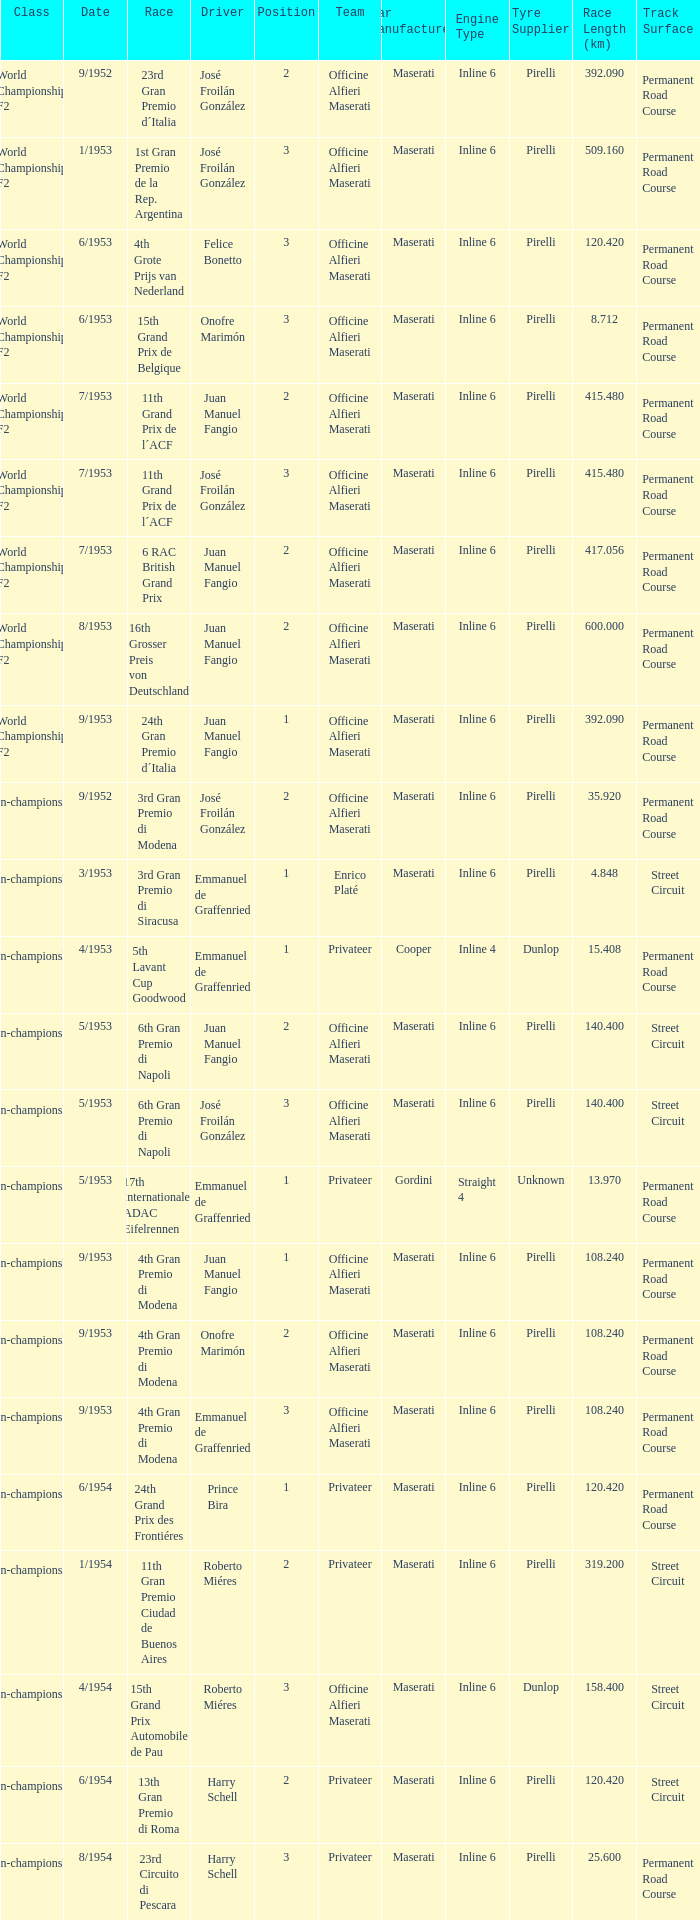What driver has a team of officine alfieri maserati and belongs to the class of non-championship f2 and has a position of 2, as well as a date of 9/1952? José Froilán González. Parse the table in full. {'header': ['Class', 'Date', 'Race', 'Driver', 'Position', 'Team', 'Car Manufacturer', 'Engine Type', 'Tyre Supplier', 'Race Length (km)', 'Track Surface'], 'rows': [['World Championship F2', '9/1952', '23rd Gran Premio d´Italia', 'José Froilán González', '2', 'Officine Alfieri Maserati', 'Maserati', 'Inline 6', 'Pirelli', '392.090', 'Permanent Road Course'], ['World Championship F2', '1/1953', '1st Gran Premio de la Rep. Argentina', 'José Froilán González', '3', 'Officine Alfieri Maserati', 'Maserati', 'Inline 6', 'Pirelli', '509.160', 'Permanent Road Course'], ['World Championship F2', '6/1953', '4th Grote Prijs van Nederland', 'Felice Bonetto', '3', 'Officine Alfieri Maserati', 'Maserati', 'Inline 6', 'Pirelli', '120.420', 'Permanent Road Course'], ['World Championship F2', '6/1953', '15th Grand Prix de Belgique', 'Onofre Marimón', '3', 'Officine Alfieri Maserati', 'Maserati', 'Inline 6', 'Pirelli', '8.712', 'Permanent Road Course'], ['World Championship F2', '7/1953', '11th Grand Prix de l´ACF', 'Juan Manuel Fangio', '2', 'Officine Alfieri Maserati', 'Maserati', 'Inline 6', 'Pirelli', '415.480', 'Permanent Road Course'], ['World Championship F2', '7/1953', '11th Grand Prix de l´ACF', 'José Froilán González', '3', 'Officine Alfieri Maserati', 'Maserati', 'Inline 6', 'Pirelli', '415.480', 'Permanent Road Course'], ['World Championship F2', '7/1953', '6 RAC British Grand Prix', 'Juan Manuel Fangio', '2', 'Officine Alfieri Maserati', 'Maserati', 'Inline 6', 'Pirelli', '417.056', 'Permanent Road Course'], ['World Championship F2', '8/1953', '16th Grosser Preis von Deutschland', 'Juan Manuel Fangio', '2', 'Officine Alfieri Maserati', 'Maserati', 'Inline 6', 'Pirelli', '600.000', 'Permanent Road Course'], ['World Championship F2', '9/1953', '24th Gran Premio d´Italia', 'Juan Manuel Fangio', '1', 'Officine Alfieri Maserati', 'Maserati', 'Inline 6', 'Pirelli', '392.090', 'Permanent Road Course'], ['Non-championship F2', '9/1952', '3rd Gran Premio di Modena', 'José Froilán González', '2', 'Officine Alfieri Maserati', 'Maserati', 'Inline 6', 'Pirelli', '35.920', 'Permanent Road Course'], ['Non-championship F2', '3/1953', '3rd Gran Premio di Siracusa', 'Emmanuel de Graffenried', '1', 'Enrico Platé', 'Maserati', 'Inline 6', 'Pirelli', '4.848', 'Street Circuit'], ['Non-championship F2', '4/1953', '5th Lavant Cup Goodwood', 'Emmanuel de Graffenried', '1', 'Privateer', 'Cooper', 'Inline 4', 'Dunlop', '15.408', 'Permanent Road Course'], ['Non-championship F2', '5/1953', '6th Gran Premio di Napoli', 'Juan Manuel Fangio', '2', 'Officine Alfieri Maserati', 'Maserati', 'Inline 6', 'Pirelli', '140.400', 'Street Circuit'], ['Non-championship F2', '5/1953', '6th Gran Premio di Napoli', 'José Froilán González', '3', 'Officine Alfieri Maserati', 'Maserati', 'Inline 6', 'Pirelli', '140.400', 'Street Circuit'], ['Non-championship F2', '5/1953', '17th Internationales ADAC Eifelrennen', 'Emmanuel de Graffenried', '1', 'Privateer', 'Gordini', 'Straight 4', 'Unknown', '13.970', 'Permanent Road Course'], ['Non-championship F2', '9/1953', '4th Gran Premio di Modena', 'Juan Manuel Fangio', '1', 'Officine Alfieri Maserati', 'Maserati', 'Inline 6', 'Pirelli', '108.240', 'Permanent Road Course'], ['Non-championship F2', '9/1953', '4th Gran Premio di Modena', 'Onofre Marimón', '2', 'Officine Alfieri Maserati', 'Maserati', 'Inline 6', 'Pirelli', '108.240', 'Permanent Road Course'], ['Non-championship F2', '9/1953', '4th Gran Premio di Modena', 'Emmanuel de Graffenried', '3', 'Officine Alfieri Maserati', 'Maserati', 'Inline 6', 'Pirelli', '108.240', 'Permanent Road Course'], ['(Non-championship) F2', '6/1954', '24th Grand Prix des Frontiéres', 'Prince Bira', '1', 'Privateer', 'Maserati', 'Inline 6', 'Pirelli', '120.420', 'Permanent Road Course'], ['Non-championship F1', '1/1954', '11th Gran Premio Ciudad de Buenos Aires', 'Roberto Miéres', '2', 'Privateer', 'Maserati', 'Inline 6', 'Pirelli', '319.200', 'Street Circuit'], ['Non-championship F1', '4/1954', '15th Grand Prix Automobile de Pau', 'Roberto Miéres', '3', 'Officine Alfieri Maserati', 'Maserati', 'Inline 6', 'Dunlop', '158.400', 'Street Circuit'], ['Non-championship F1', '6/1954', '13th Gran Premio di Roma', 'Harry Schell', '2', 'Privateer', 'Maserati', 'Inline 6', 'Pirelli', '120.420', 'Street Circuit'], ['Non-championship F1', '8/1954', '23rd Circuito di Pescara', 'Harry Schell', '3', 'Privateer', 'Maserati', 'Inline 6', 'Pirelli', '25.600', 'Permanent Road Course']]} 